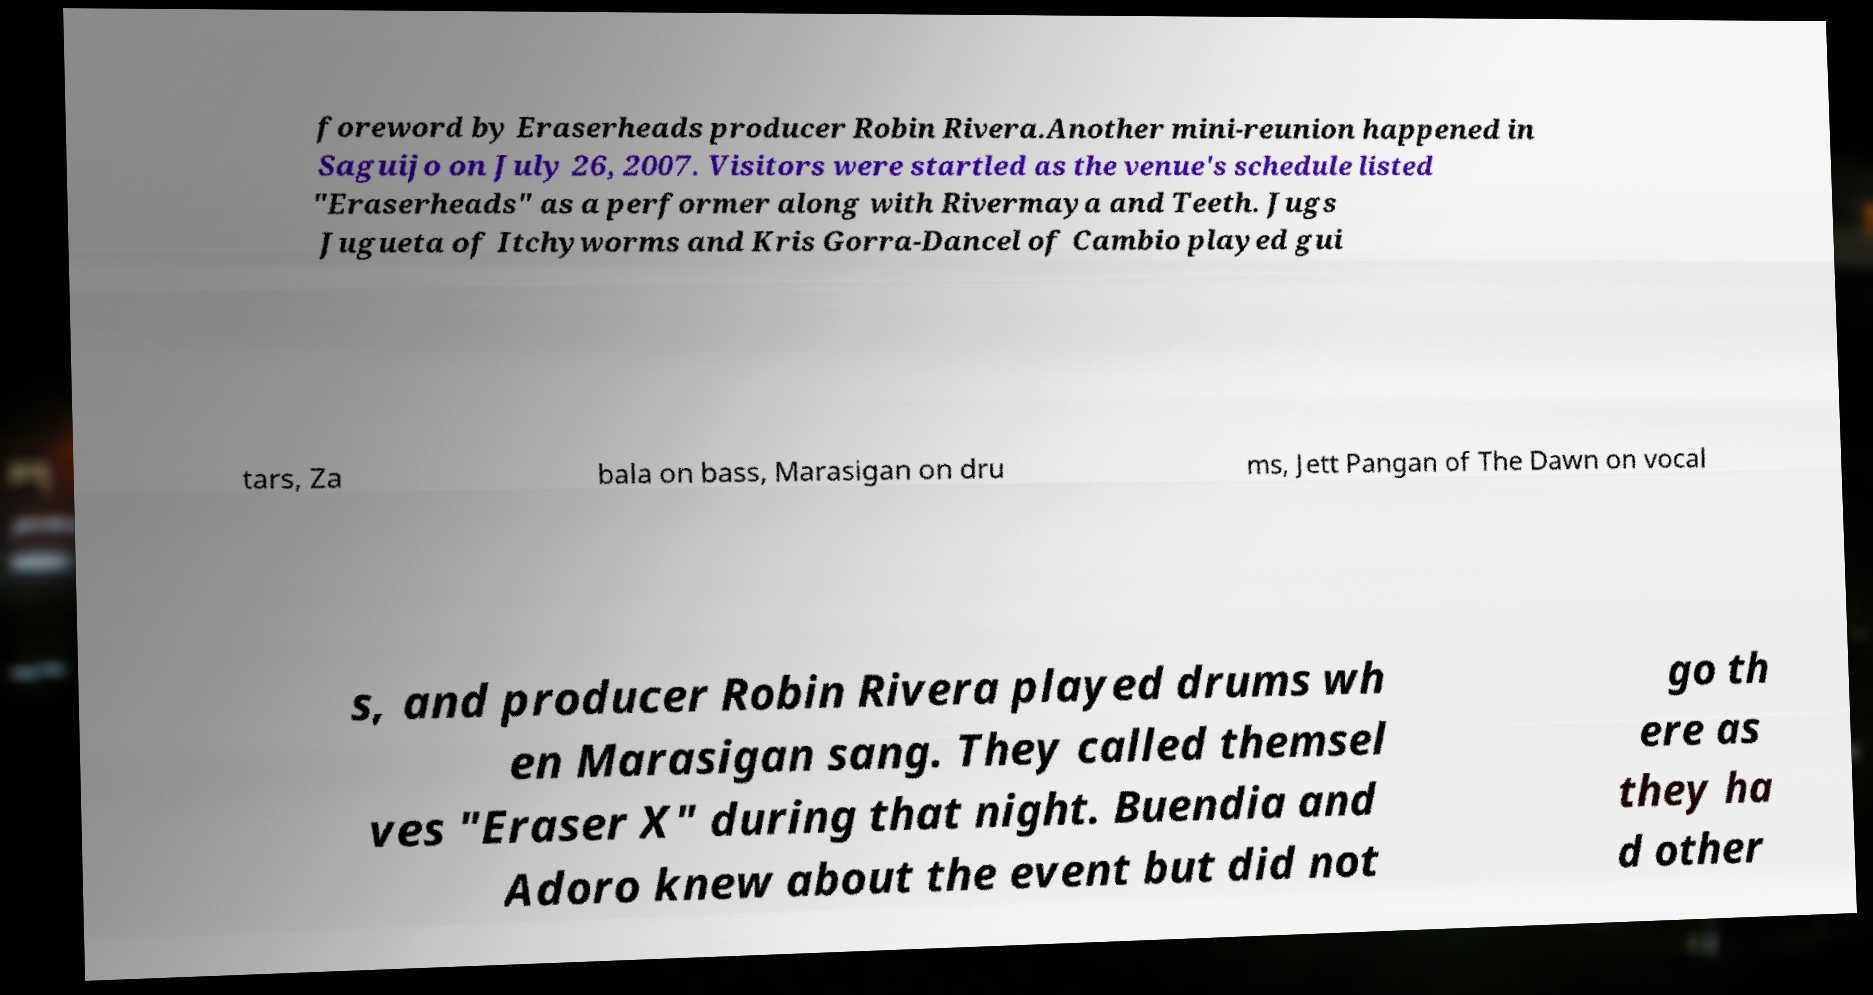Please read and relay the text visible in this image. What does it say? foreword by Eraserheads producer Robin Rivera.Another mini-reunion happened in Saguijo on July 26, 2007. Visitors were startled as the venue's schedule listed "Eraserheads" as a performer along with Rivermaya and Teeth. Jugs Jugueta of Itchyworms and Kris Gorra-Dancel of Cambio played gui tars, Za bala on bass, Marasigan on dru ms, Jett Pangan of The Dawn on vocal s, and producer Robin Rivera played drums wh en Marasigan sang. They called themsel ves "Eraser X" during that night. Buendia and Adoro knew about the event but did not go th ere as they ha d other 